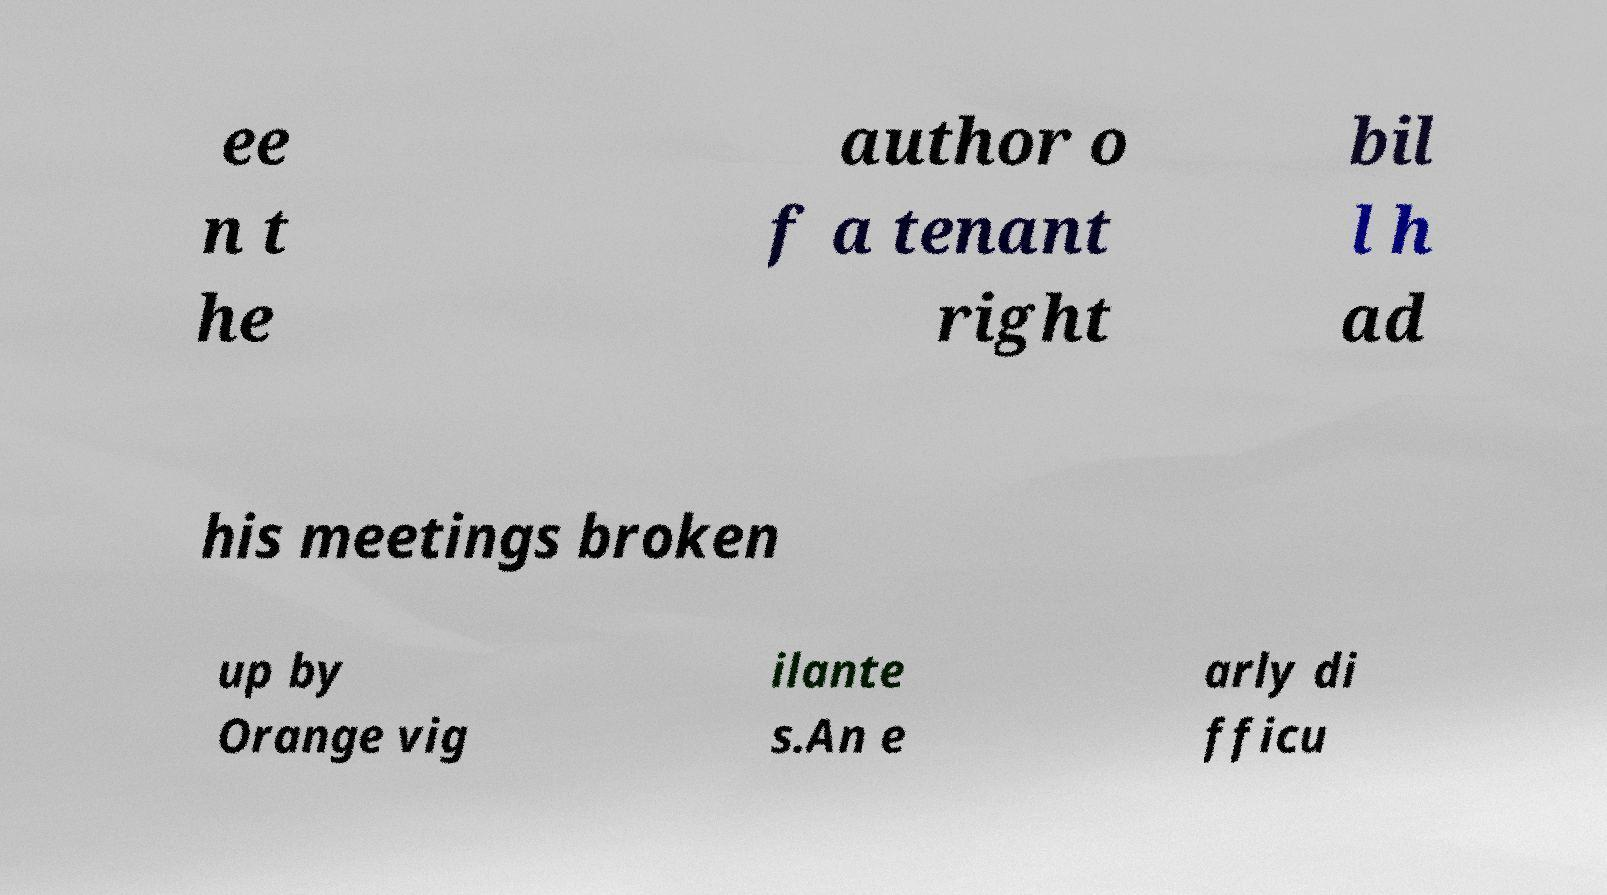For documentation purposes, I need the text within this image transcribed. Could you provide that? ee n t he author o f a tenant right bil l h ad his meetings broken up by Orange vig ilante s.An e arly di fficu 